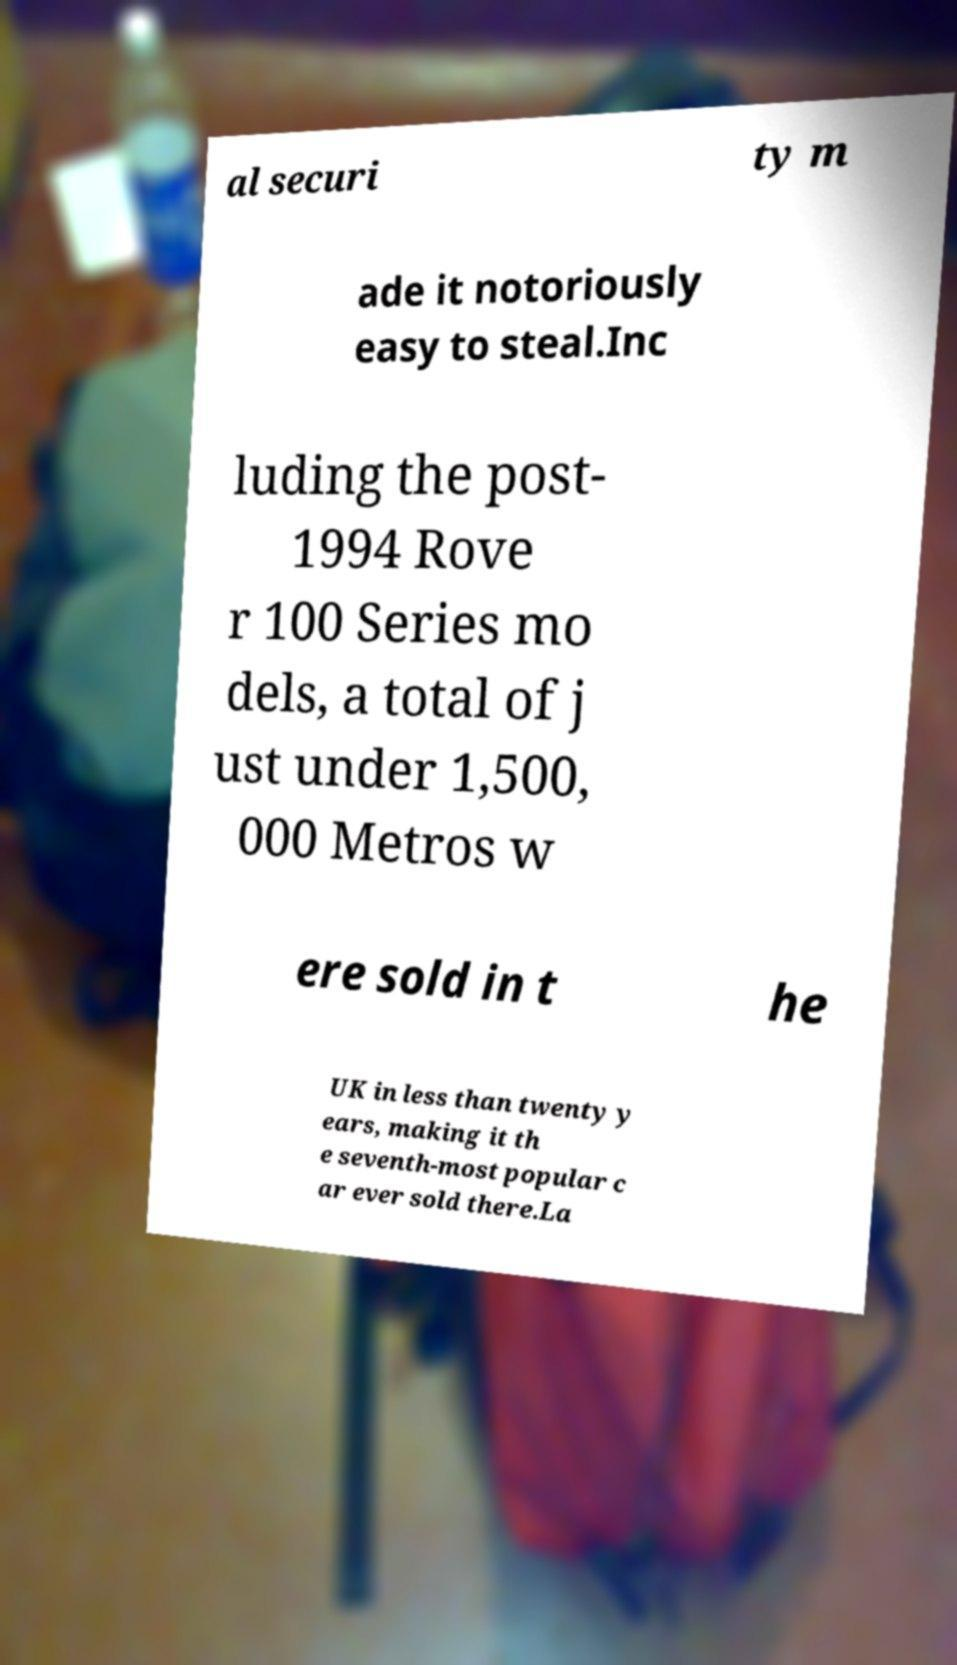I need the written content from this picture converted into text. Can you do that? al securi ty m ade it notoriously easy to steal.Inc luding the post- 1994 Rove r 100 Series mo dels, a total of j ust under 1,500, 000 Metros w ere sold in t he UK in less than twenty y ears, making it th e seventh-most popular c ar ever sold there.La 